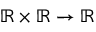Convert formula to latex. <formula><loc_0><loc_0><loc_500><loc_500>\mathbb { R } \times \mathbb { R } \rightarrow \mathbb { R }</formula> 